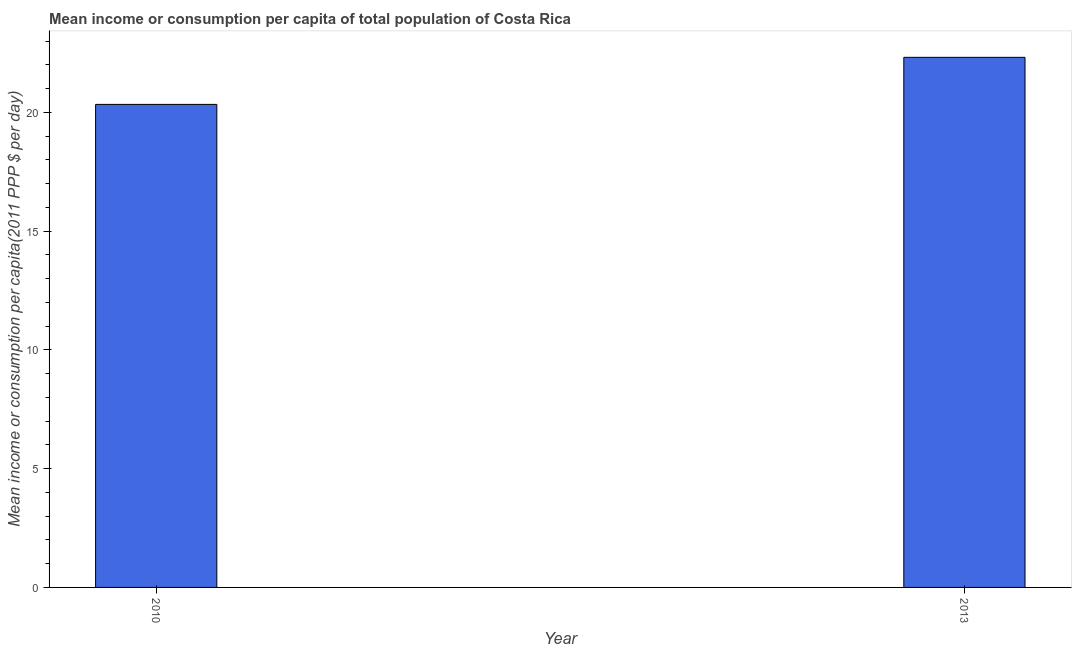Does the graph contain grids?
Give a very brief answer. No. What is the title of the graph?
Offer a terse response. Mean income or consumption per capita of total population of Costa Rica. What is the label or title of the X-axis?
Provide a succinct answer. Year. What is the label or title of the Y-axis?
Make the answer very short. Mean income or consumption per capita(2011 PPP $ per day). What is the mean income or consumption in 2013?
Offer a terse response. 22.32. Across all years, what is the maximum mean income or consumption?
Your answer should be very brief. 22.32. Across all years, what is the minimum mean income or consumption?
Offer a terse response. 20.34. In which year was the mean income or consumption minimum?
Your response must be concise. 2010. What is the sum of the mean income or consumption?
Your response must be concise. 42.66. What is the difference between the mean income or consumption in 2010 and 2013?
Offer a terse response. -1.98. What is the average mean income or consumption per year?
Give a very brief answer. 21.33. What is the median mean income or consumption?
Offer a terse response. 21.33. In how many years, is the mean income or consumption greater than 3 $?
Offer a very short reply. 2. What is the ratio of the mean income or consumption in 2010 to that in 2013?
Offer a very short reply. 0.91. Is the mean income or consumption in 2010 less than that in 2013?
Keep it short and to the point. Yes. In how many years, is the mean income or consumption greater than the average mean income or consumption taken over all years?
Provide a short and direct response. 1. How many bars are there?
Make the answer very short. 2. What is the Mean income or consumption per capita(2011 PPP $ per day) in 2010?
Provide a succinct answer. 20.34. What is the Mean income or consumption per capita(2011 PPP $ per day) in 2013?
Give a very brief answer. 22.32. What is the difference between the Mean income or consumption per capita(2011 PPP $ per day) in 2010 and 2013?
Offer a terse response. -1.98. What is the ratio of the Mean income or consumption per capita(2011 PPP $ per day) in 2010 to that in 2013?
Offer a very short reply. 0.91. 